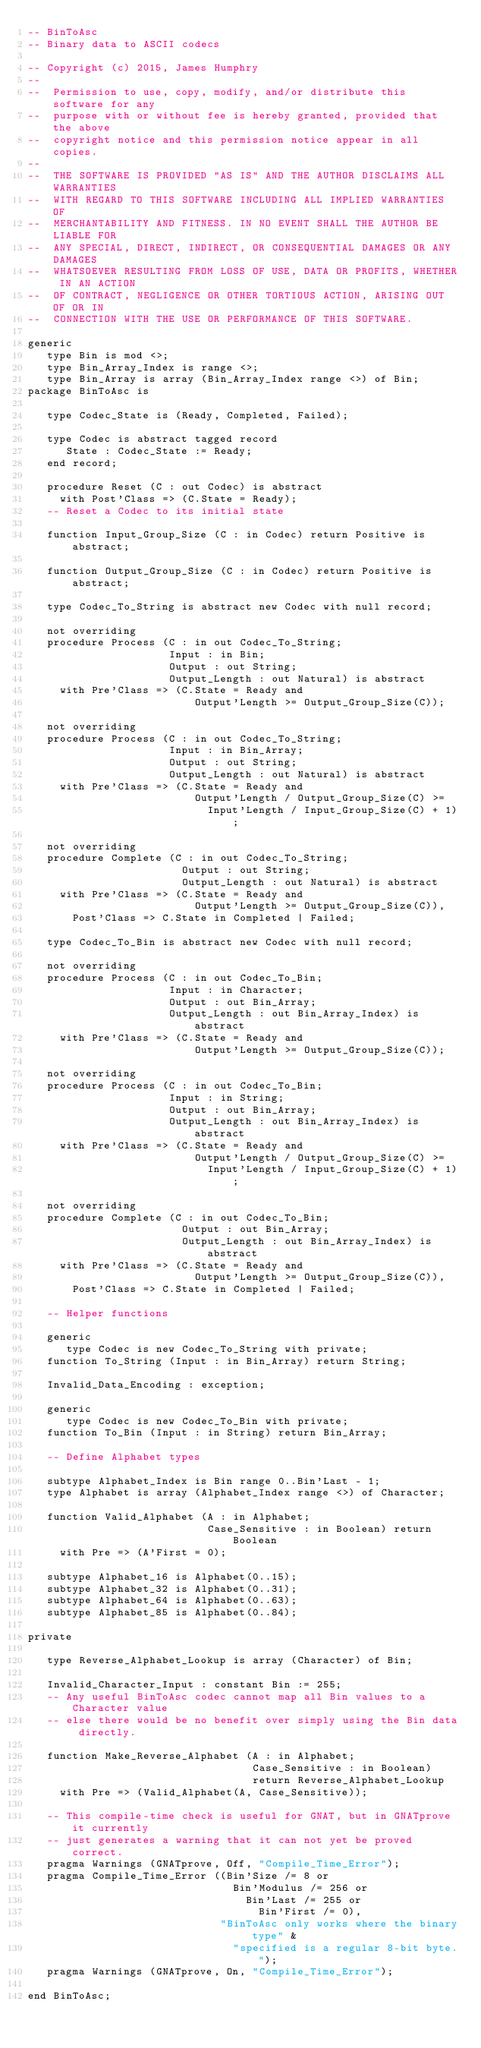<code> <loc_0><loc_0><loc_500><loc_500><_Ada_>-- BinToAsc
-- Binary data to ASCII codecs

-- Copyright (c) 2015, James Humphry
--
--  Permission to use, copy, modify, and/or distribute this software for any
--  purpose with or without fee is hereby granted, provided that the above
--  copyright notice and this permission notice appear in all copies.
--
--  THE SOFTWARE IS PROVIDED "AS IS" AND THE AUTHOR DISCLAIMS ALL WARRANTIES
--  WITH REGARD TO THIS SOFTWARE INCLUDING ALL IMPLIED WARRANTIES OF
--  MERCHANTABILITY AND FITNESS. IN NO EVENT SHALL THE AUTHOR BE LIABLE FOR
--  ANY SPECIAL, DIRECT, INDIRECT, OR CONSEQUENTIAL DAMAGES OR ANY DAMAGES
--  WHATSOEVER RESULTING FROM LOSS OF USE, DATA OR PROFITS, WHETHER IN AN ACTION
--  OF CONTRACT, NEGLIGENCE OR OTHER TORTIOUS ACTION, ARISING OUT OF OR IN
--  CONNECTION WITH THE USE OR PERFORMANCE OF THIS SOFTWARE.

generic
   type Bin is mod <>;
   type Bin_Array_Index is range <>;
   type Bin_Array is array (Bin_Array_Index range <>) of Bin;
package BinToAsc is

   type Codec_State is (Ready, Completed, Failed);

   type Codec is abstract tagged record
      State : Codec_State := Ready;
   end record;

   procedure Reset (C : out Codec) is abstract
     with Post'Class => (C.State = Ready);
   -- Reset a Codec to its initial state

   function Input_Group_Size (C : in Codec) return Positive is abstract;

   function Output_Group_Size (C : in Codec) return Positive is abstract;

   type Codec_To_String is abstract new Codec with null record;

   not overriding
   procedure Process (C : in out Codec_To_String;
                      Input : in Bin;
                      Output : out String;
                      Output_Length : out Natural) is abstract
     with Pre'Class => (C.State = Ready and
                          Output'Length >= Output_Group_Size(C));

   not overriding
   procedure Process (C : in out Codec_To_String;
                      Input : in Bin_Array;
                      Output : out String;
                      Output_Length : out Natural) is abstract
     with Pre'Class => (C.State = Ready and
                          Output'Length / Output_Group_Size(C) >=
                            Input'Length / Input_Group_Size(C) + 1);

   not overriding
   procedure Complete (C : in out Codec_To_String;
                        Output : out String;
                        Output_Length : out Natural) is abstract
     with Pre'Class => (C.State = Ready and
                          Output'Length >= Output_Group_Size(C)),
       Post'Class => C.State in Completed | Failed;

   type Codec_To_Bin is abstract new Codec with null record;

   not overriding
   procedure Process (C : in out Codec_To_Bin;
                      Input : in Character;
                      Output : out Bin_Array;
                      Output_Length : out Bin_Array_Index) is abstract
     with Pre'Class => (C.State = Ready and
                          Output'Length >= Output_Group_Size(C));

   not overriding
   procedure Process (C : in out Codec_To_Bin;
                      Input : in String;
                      Output : out Bin_Array;
                      Output_Length : out Bin_Array_Index) is abstract
     with Pre'Class => (C.State = Ready and
                          Output'Length / Output_Group_Size(C) >=
                            Input'Length / Input_Group_Size(C) + 1);

   not overriding
   procedure Complete (C : in out Codec_To_Bin;
                        Output : out Bin_Array;
                        Output_Length : out Bin_Array_Index) is abstract
     with Pre'Class => (C.State = Ready and
                          Output'Length >= Output_Group_Size(C)),
       Post'Class => C.State in Completed | Failed;

   -- Helper functions

   generic
      type Codec is new Codec_To_String with private;
   function To_String (Input : in Bin_Array) return String;

   Invalid_Data_Encoding : exception;

   generic
      type Codec is new Codec_To_Bin with private;
   function To_Bin (Input : in String) return Bin_Array;

   -- Define Alphabet types

   subtype Alphabet_Index is Bin range 0..Bin'Last - 1;
   type Alphabet is array (Alphabet_Index range <>) of Character;

   function Valid_Alphabet (A : in Alphabet;
                            Case_Sensitive : in Boolean) return Boolean
     with Pre => (A'First = 0);

   subtype Alphabet_16 is Alphabet(0..15);
   subtype Alphabet_32 is Alphabet(0..31);
   subtype Alphabet_64 is Alphabet(0..63);
   subtype Alphabet_85 is Alphabet(0..84);

private

   type Reverse_Alphabet_Lookup is array (Character) of Bin;

   Invalid_Character_Input : constant Bin := 255;
   -- Any useful BinToAsc codec cannot map all Bin values to a Character value
   -- else there would be no benefit over simply using the Bin data directly.

   function Make_Reverse_Alphabet (A : in Alphabet;
                                   Case_Sensitive : in Boolean)
                                   return Reverse_Alphabet_Lookup
     with Pre => (Valid_Alphabet(A, Case_Sensitive));

   -- This compile-time check is useful for GNAT, but in GNATprove it currently
   -- just generates a warning that it can not yet be proved correct.
   pragma Warnings (GNATprove, Off, "Compile_Time_Error");
   pragma Compile_Time_Error ((Bin'Size /= 8 or
                                Bin'Modulus /= 256 or
                                  Bin'Last /= 255 or
                                    Bin'First /= 0),
                              "BinToAsc only works where the binary type" &
                                "specified is a regular 8-bit byte.");
   pragma Warnings (GNATprove, On, "Compile_Time_Error");

end BinToAsc;
</code> 